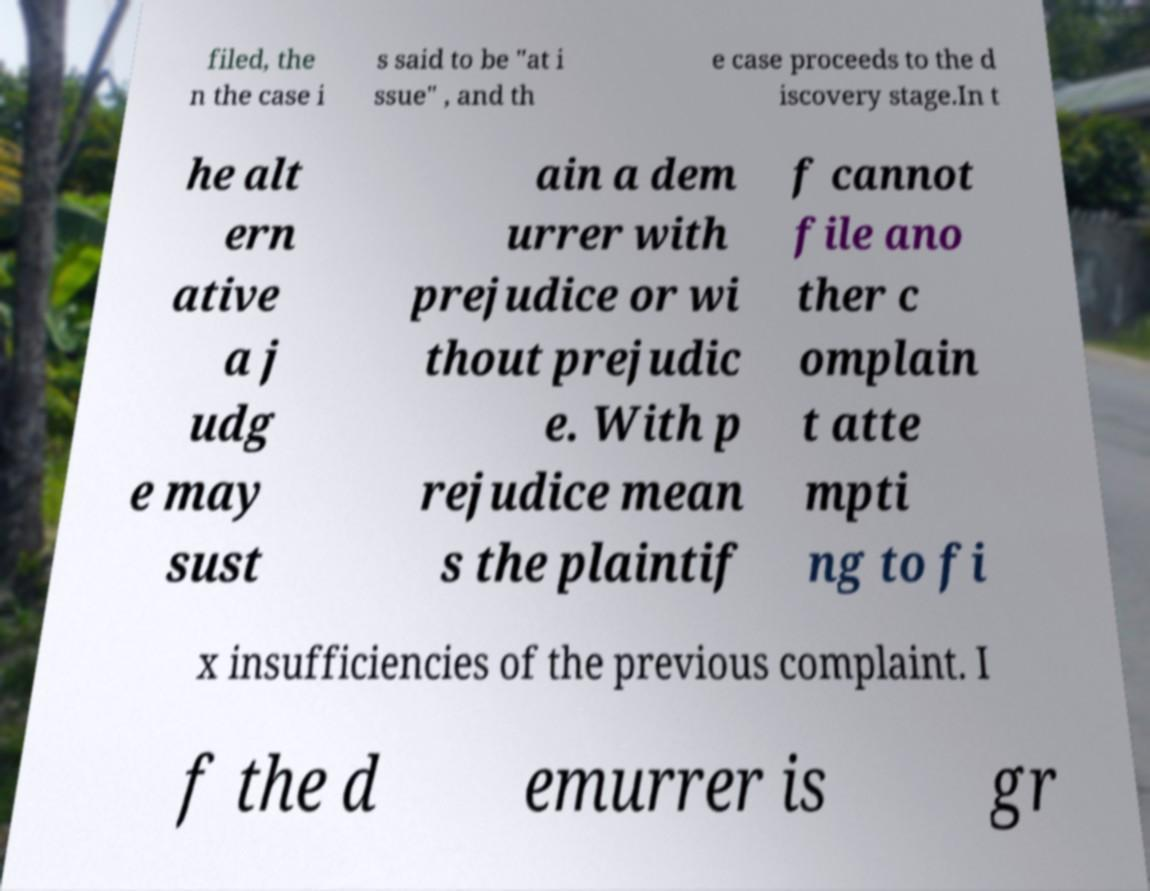There's text embedded in this image that I need extracted. Can you transcribe it verbatim? filed, the n the case i s said to be "at i ssue" , and th e case proceeds to the d iscovery stage.In t he alt ern ative a j udg e may sust ain a dem urrer with prejudice or wi thout prejudic e. With p rejudice mean s the plaintif f cannot file ano ther c omplain t atte mpti ng to fi x insufficiencies of the previous complaint. I f the d emurrer is gr 